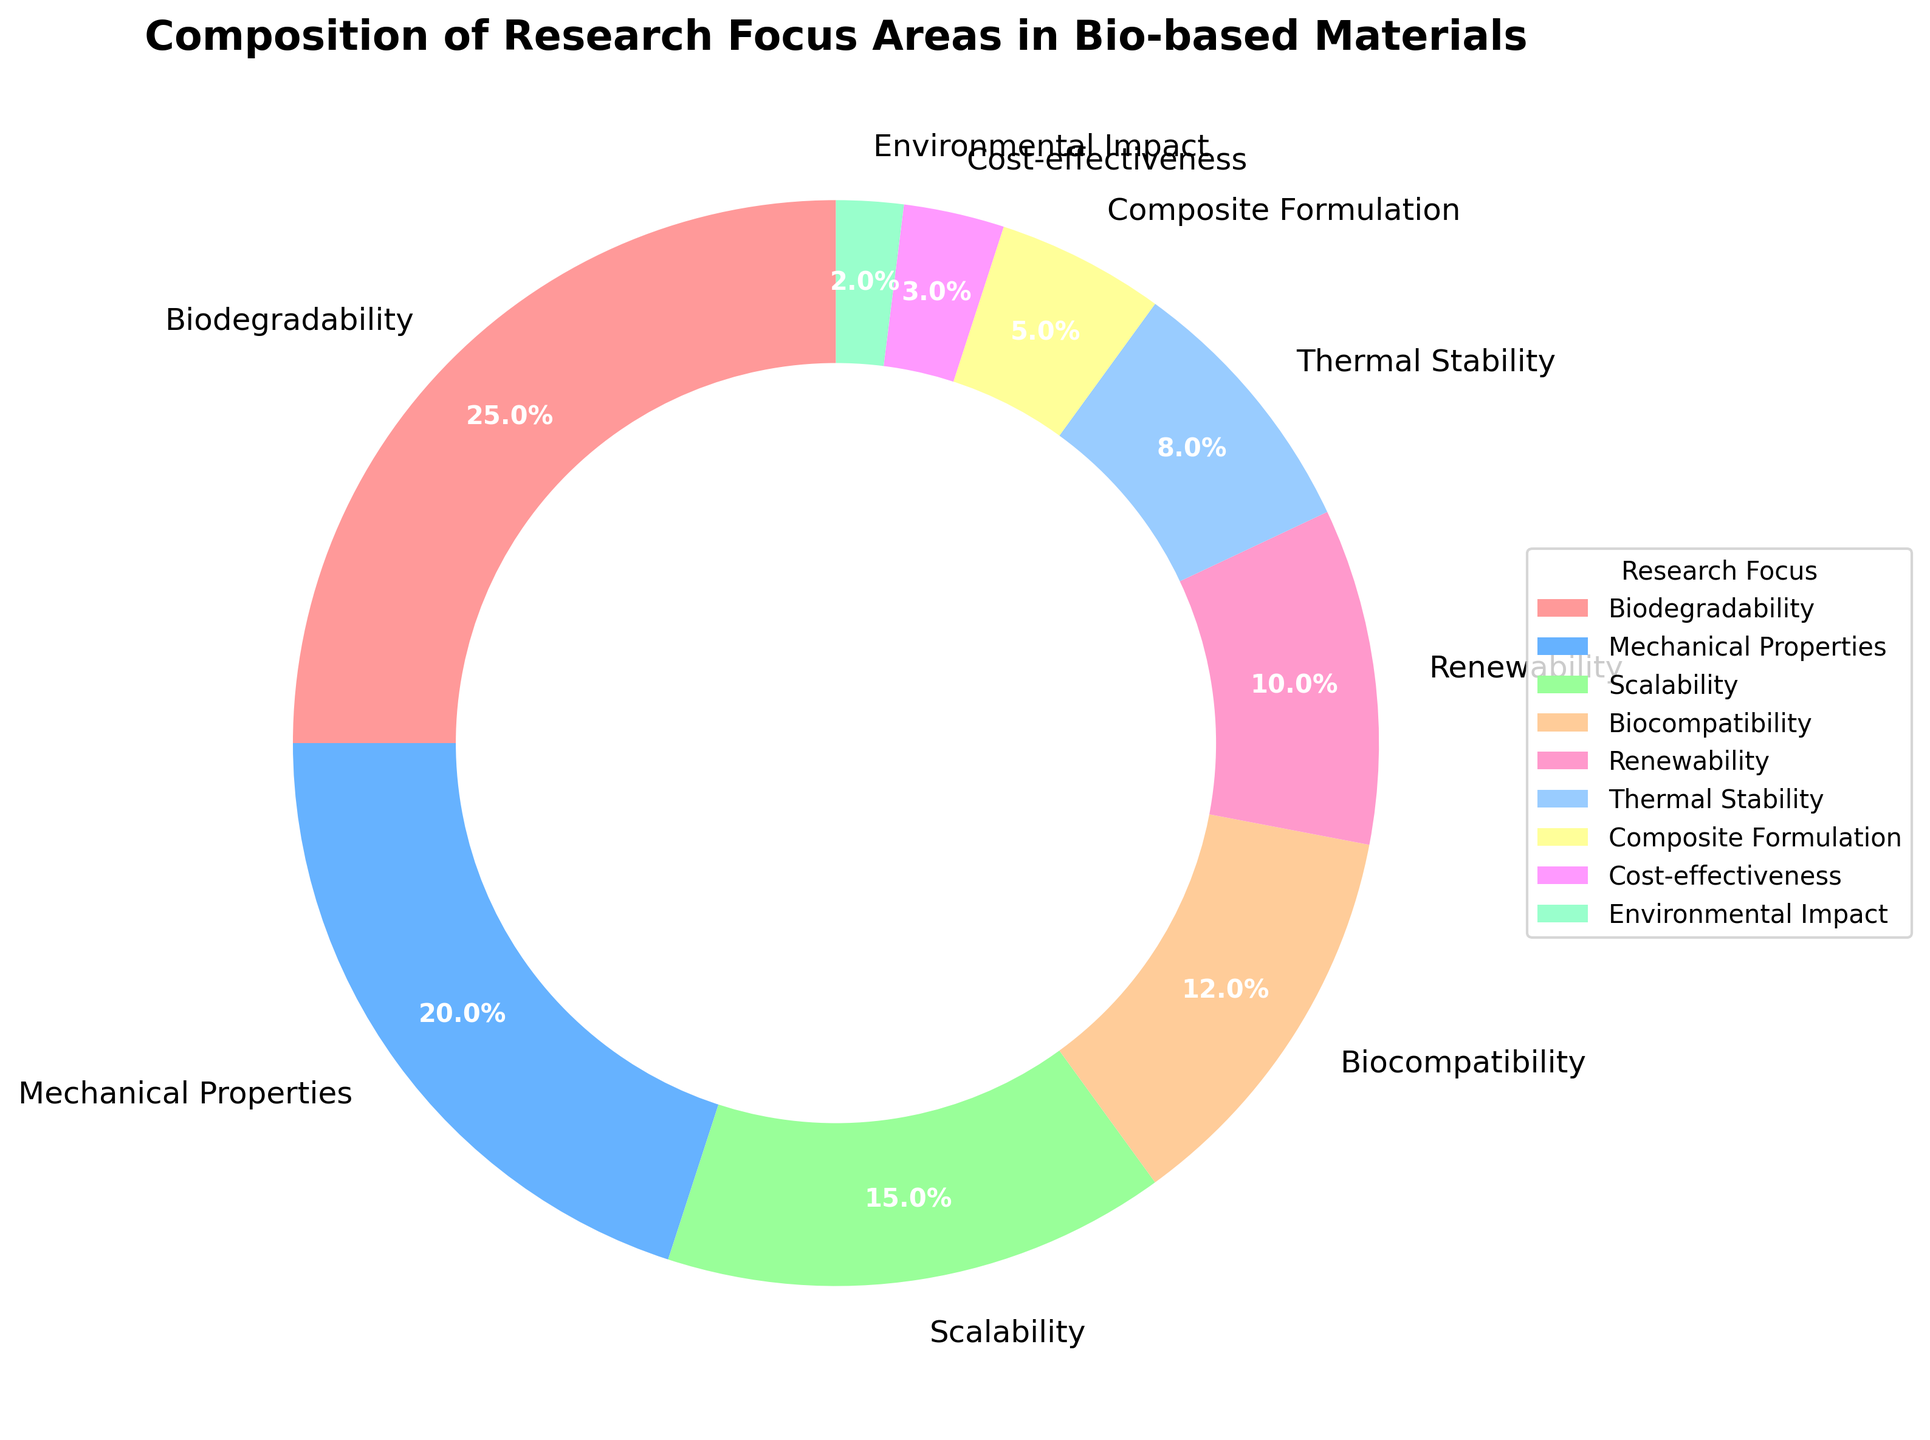What is the most common research focus area in bio-based materials? Biodegradability is the largest segment in the pie chart, indicating it has the highest percentage.
Answer: Biodegradability Which research focus areas together make up more than 50% of the composition? Adding the percentages, Biodegradability (25%) + Mechanical Properties (20%) + Scalability (15%) = 60%, which is more than 50%.
Answer: Biodegradability, Mechanical Properties, Scalability How much greater is the percentage for Mechanical Properties compared to Cost-effectiveness? Subtracting the percentage for Cost-effectiveness (3%) from Mechanical Properties (20%), we get 20% - 3% = 17%.
Answer: 17% Which research focus area has the second smallest proportion, and what is its percentage? The research focus area with the second smallest proportion is identified by finding the next smallest percentage after Environmental Impact (2%), which is Cost-effectiveness (3%).
Answer: Cost-effectiveness, 3% What is the total percentage of Biocompatibility, Renewability, and Thermal Stability combined? Adding the percentages, Biocompatibility (12%) + Renewability (10%) + Thermal Stability (8%) = 30%.
Answer: 30% Compare the percentage of Composite Formulation to that of Biocompatibility. Which is larger and by how much? By comparing the percentages, Biocompatibility (12%) is larger than Composite Formulation (5%). The difference is 12% - 5% = 7%.
Answer: Biocompatibility by 7% Which research focus area is colored blue, and what percentage does it represent? By observing the colors in the pie chart, we recognize that Mechanical Properties is the one in blue, representing 20%.
Answer: Mechanical Properties, 20% If you combine the areas with less than 10% each, what percentage of the total composition do they represent? Adding the percentages for areas with less than 10%: Renewability (10%) + Thermal Stability (8%) + Composite Formulation (5%) + Cost-effectiveness (3%) + Environmental Impact (2%) = 28%.
Answer: 28% What two research focus areas collectively have the smallest share of the total percentage? The smallest shares are Environmental Impact (2%) and Cost-effectiveness (3%). Together they make up 2% + 3% = 5%.
Answer: Environmental Impact and Cost-effectiveness Which three research focus areas are between 10% and 20%? By inspecting the percentages: Biocompatibility (12%), Renewability (10%), and Scalability (15%) all fall between 10% and 20%.
Answer: Biocompatibility, Renewability, Scalability 